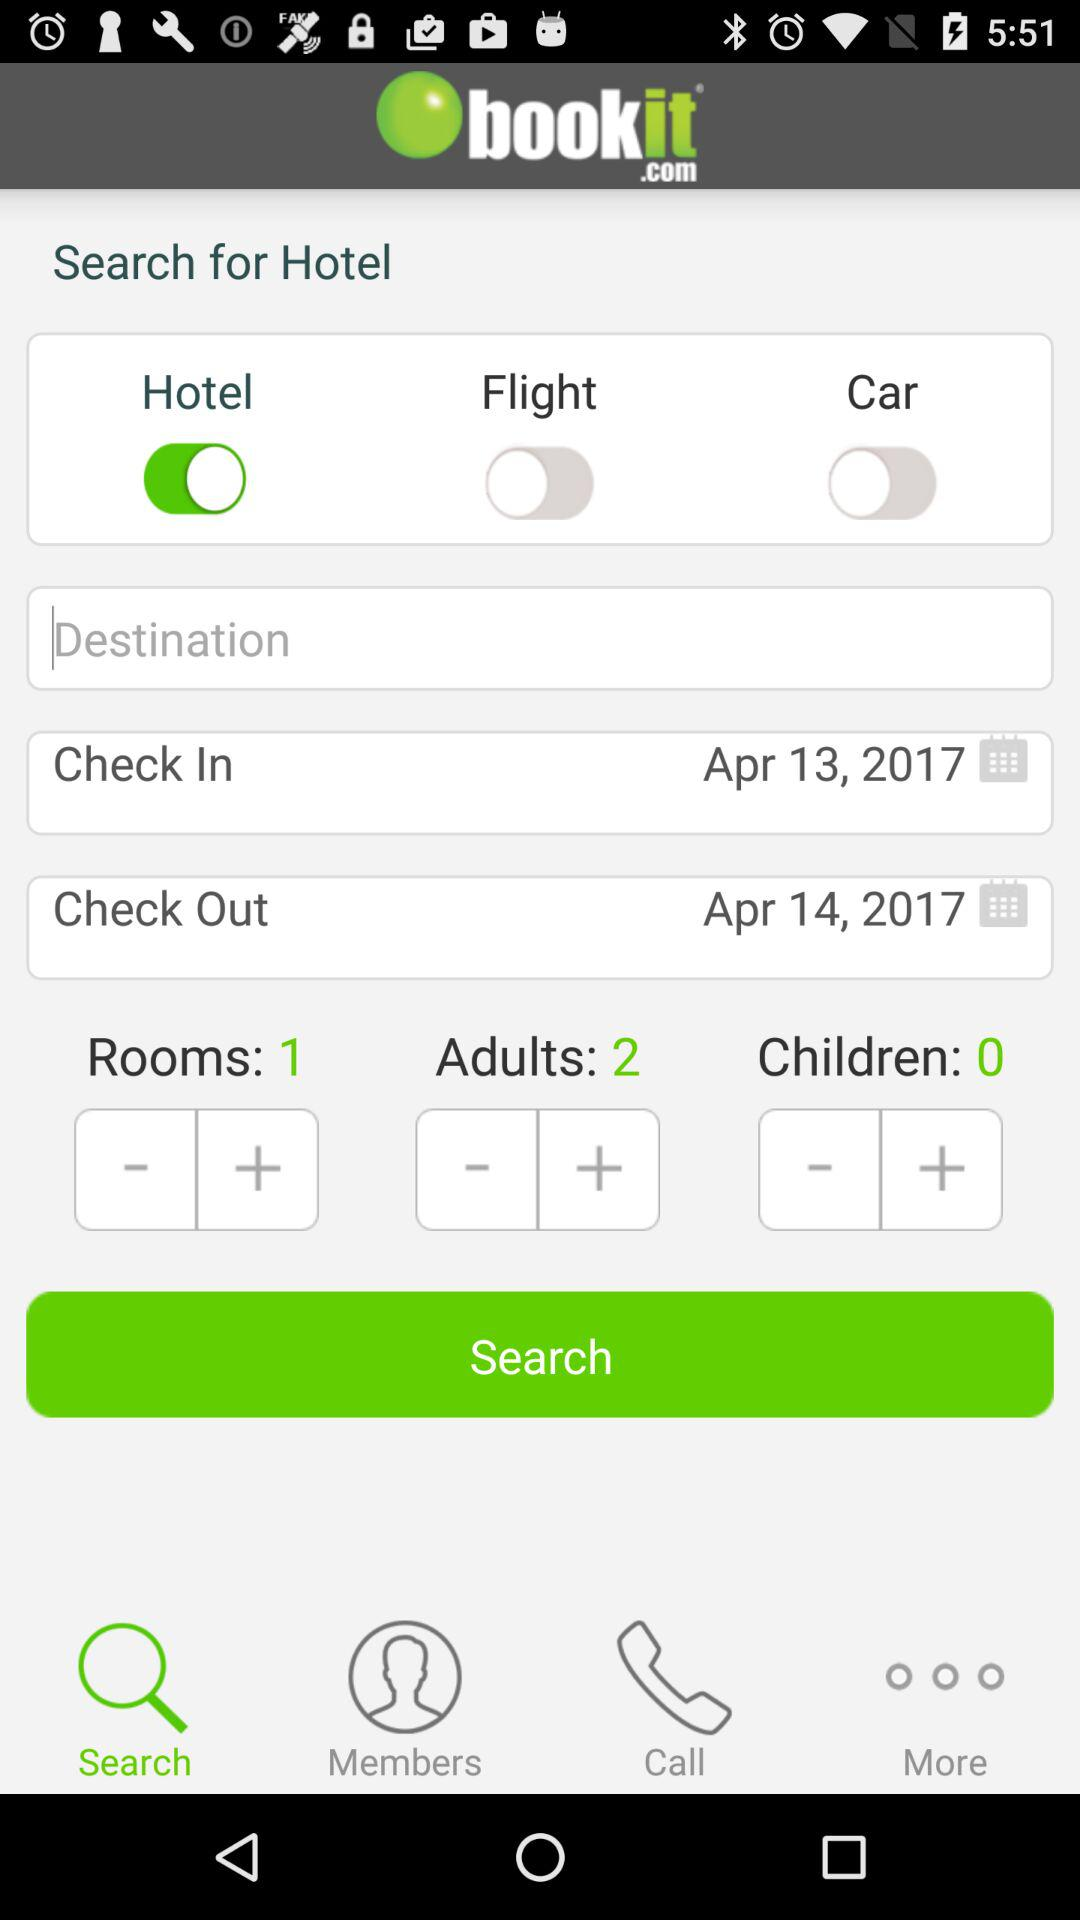What is the check-out date? The check-out date is April 14, 2017. 